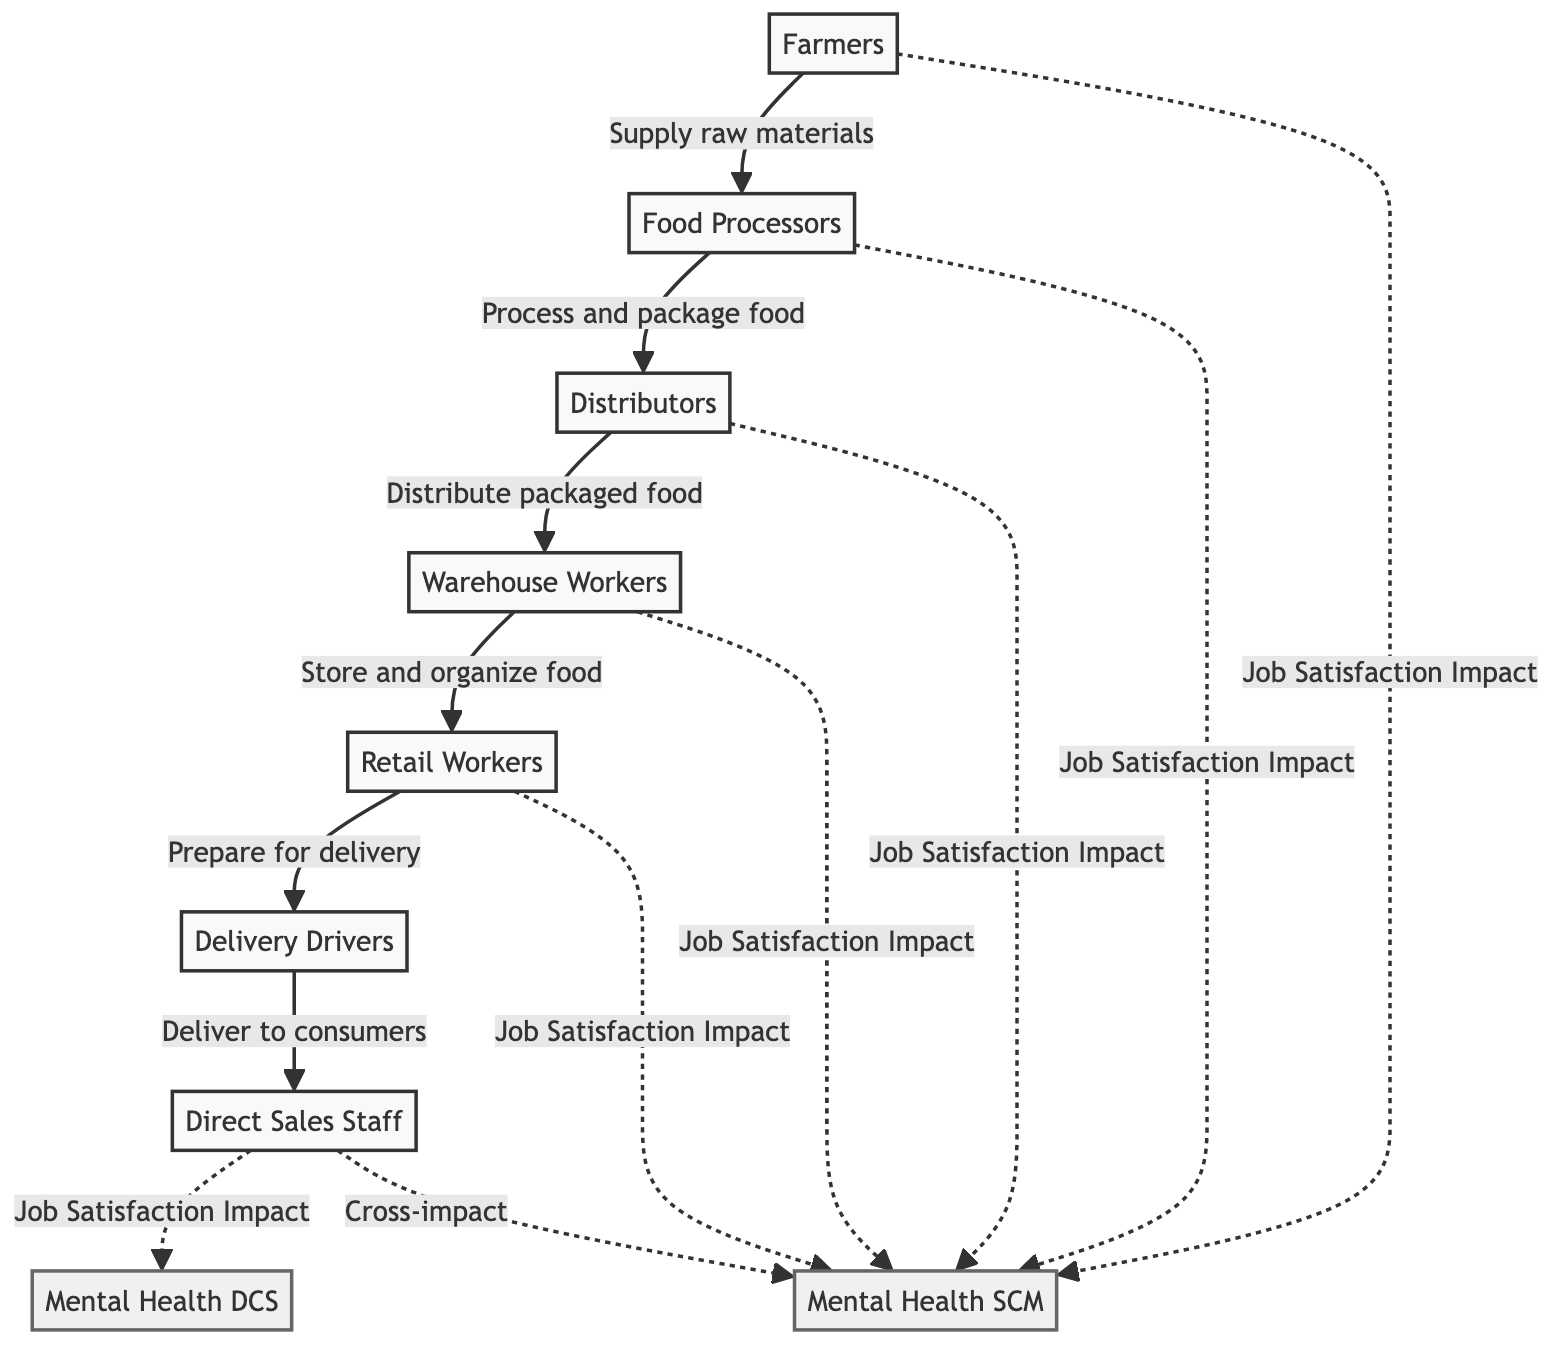What are the main nodes in the food chain? The main nodes in the food chain are Farmers, Food Processors, Distributors, Warehouse Workers, Retail Workers, Delivery Drivers, and Direct Sales Staff. Each of these entities represents a stage in the supply chain for food products.
Answer: Farmers, Food Processors, Distributors, Warehouse Workers, Retail Workers, Delivery Drivers, Direct Sales Staff Which node delivers food to consumers? The node that delivers food to consumers is the Delivery Drivers. They play a crucial role in transporting the packaged food from retail workers to end consumers.
Answer: Delivery Drivers How many job satisfaction impacts are related to Mental Health in Supply Chain Management? There are five job satisfaction impacts related to Mental Health in Supply Chain Management. These impacts originate from Farmers, Food Processors, Distributors, Warehouse Workers, and Retail Workers.
Answer: 5 What two nodes have a cross-impact on Mental Health in Supply Chain Management? The two nodes with a cross-impact on Mental Health in Supply Chain Management are Direct Sales Staff and Mental Health SCM. The diagram indicates that the job satisfaction of Direct Sales Staff affects both their mental health and that of the entire supply chain management.
Answer: Direct Sales Staff, Mental Health SCM Which node is associated with Mental Health in Direct Consumer Sales? The node associated with Mental Health in Direct Consumer Sales is Mental Health DCS. This node reflects the mental health concerns specifically impacting those involved in direct consumer sales activities.
Answer: Mental Health DCS What is the relationship between Food Processors and Mental Health SCM? The relationship is that Food Processors impact job satisfaction, which in turn affects Mental Health in Supply Chain Management. This indicates that employee satisfaction within food processing can influence mental health outcomes.
Answer: Job Satisfaction Impact Which two entities are located at the beginning and end of the supply chain? Farmers are located at the beginning, supplying raw materials, while Direct Sales Staff are at the end, selling directly to consumers. This shows the flow of products starting from raw materials to consumer sales.
Answer: Farmers, Direct Sales Staff How many direct linkages are there from Farmers to other nodes? Farmers have one direct linkage to Food Processors, representing the supply of raw materials in the food chain. This indicates the first step in the supply chain process.
Answer: 1 